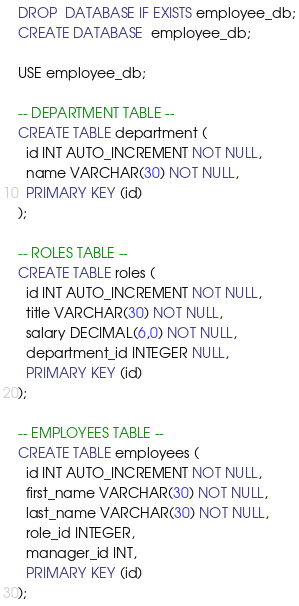<code> <loc_0><loc_0><loc_500><loc_500><_SQL_>DROP  DATABASE IF EXISTS employee_db;
CREATE DATABASE  employee_db; 

USE employee_db;

-- DEPARTMENT TABLE --
CREATE TABLE department (
  id INT AUTO_INCREMENT NOT NULL,
  name VARCHAR(30) NOT NULL,
  PRIMARY KEY (id)
);

-- ROLES TABLE --
CREATE TABLE roles (
  id INT AUTO_INCREMENT NOT NULL,
  title VARCHAR(30) NOT NULL,
  salary DECIMAL(6,0) NOT NULL,
  department_id INTEGER NULL,
  PRIMARY KEY (id)
);

-- EMPLOYEES TABLE --
CREATE TABLE employees (
  id INT AUTO_INCREMENT NOT NULL,
  first_name VARCHAR(30) NOT NULL,
  last_name VARCHAR(30) NOT NULL,
  role_id INTEGER,
  manager_id INT,
  PRIMARY KEY (id)
);</code> 